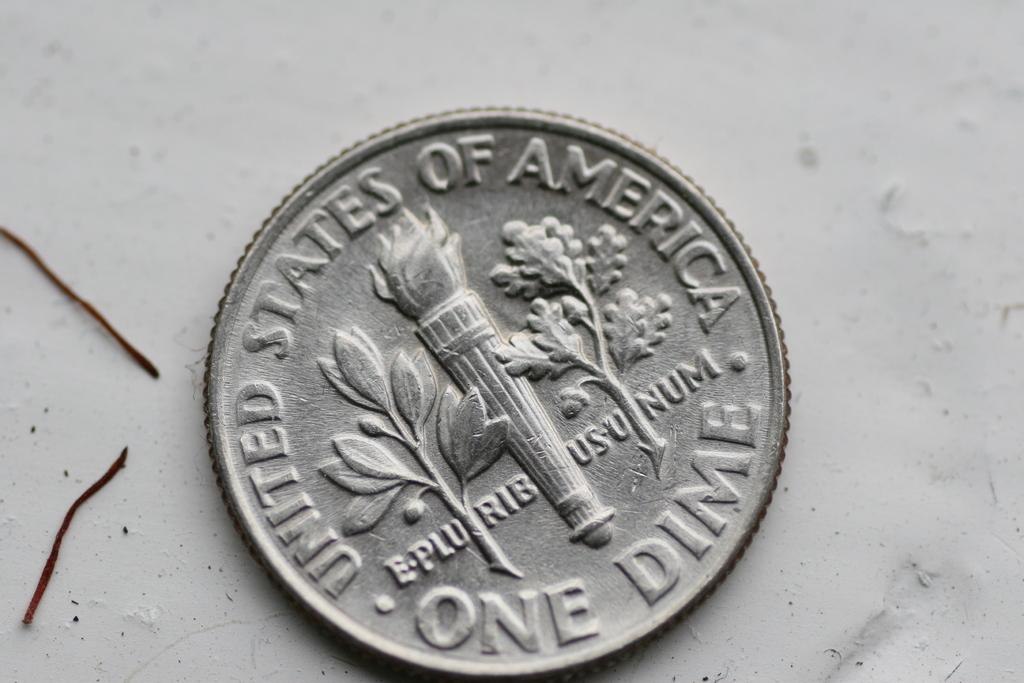<image>
Share a concise interpretation of the image provided. A United States of America One Dime coin 